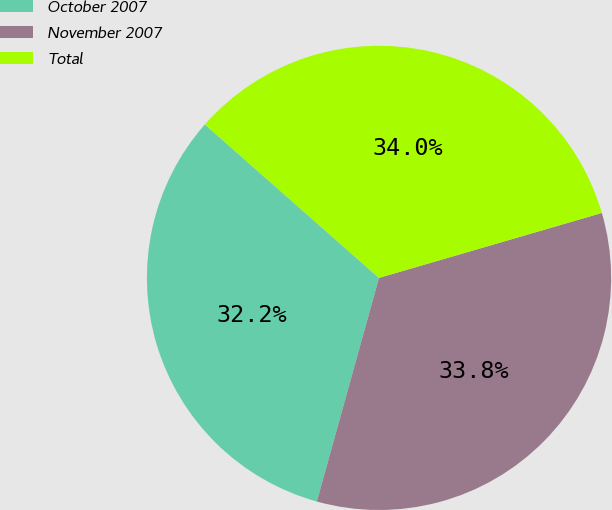<chart> <loc_0><loc_0><loc_500><loc_500><pie_chart><fcel>October 2007<fcel>November 2007<fcel>Total<nl><fcel>32.18%<fcel>33.83%<fcel>33.99%<nl></chart> 